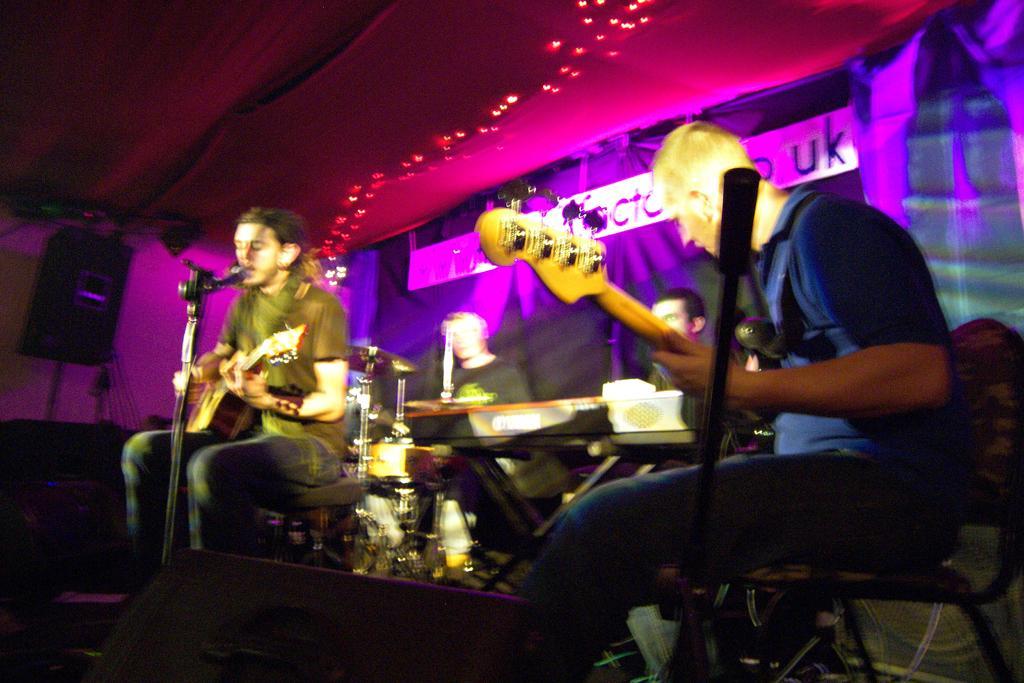In one or two sentences, can you explain what this image depicts? In this picture there are group of people those who are performing the music on the stage, the person who is sitting at the left side of the image, he is playing the guitar and singing in the mic and the person who is sitting at the right side of the image he is playing the guitar, and the person who is sitting at the center of the image he is playing the drums and there is a poster behind them, there are colorful lights around the area of the image and there is a speaker at the left side of the image. 